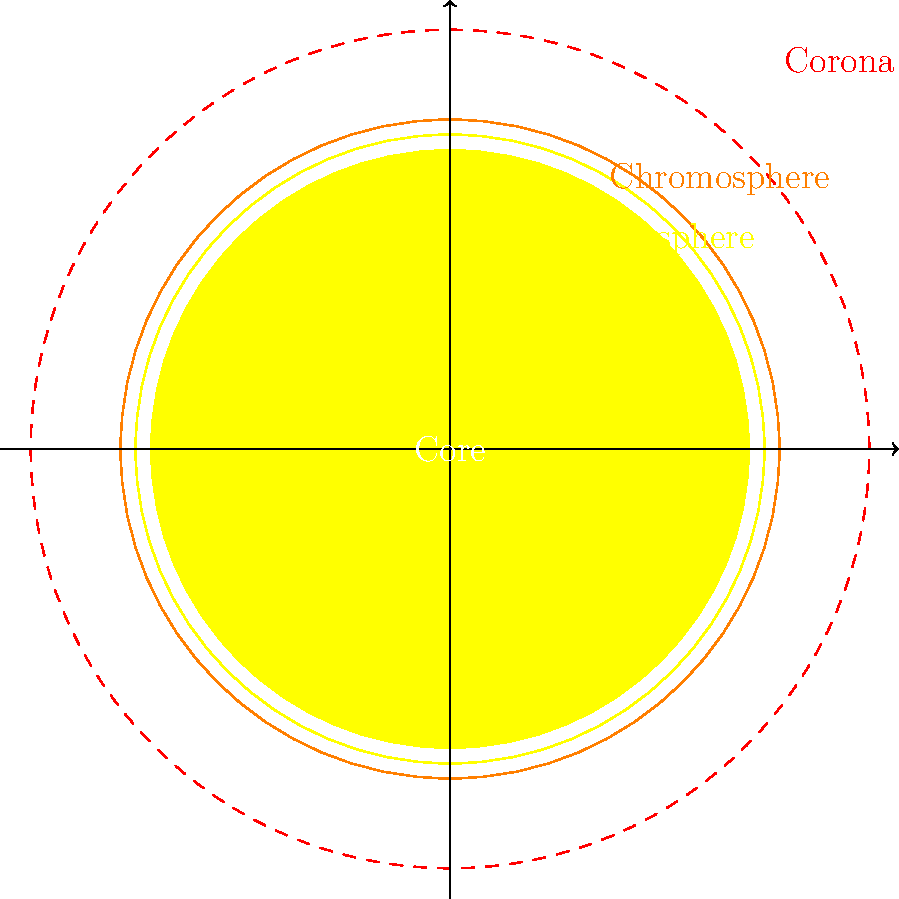In the context of creating 8-bit music inspired by astronomical phenomena, which layer of the Sun's atmosphere would be best represented by high-frequency, shimmering sounds due to its extremely high temperature and dynamic nature? To answer this question, let's break down the layers of the Sun's atmosphere and their characteristics:

1. Photosphere: This is the visible surface of the Sun. It's relatively cool (about 5,800 K) and dense.

2. Chromosphere: This layer is hotter than the photosphere (about 4,000 to 8,000 K) and less dense. It appears reddish during solar eclipses.

3. Corona: This is the outermost layer of the Sun's atmosphere. It's extremely hot (over 1,000,000 K) and less dense than the inner layers.

The corona is the best choice for high-frequency, shimmering sounds in 8-bit music because:

a) It's the hottest layer, with temperatures reaching millions of degrees Kelvin.
b) It's highly dynamic, with solar wind, flares, and coronal mass ejections originating here.
c) Its appearance during solar eclipses is described as shimmering or flickering, which aligns well with high-frequency sounds in music.

In 8-bit music composition, high-frequency sounds could be used to represent the intense energy and dynamic nature of the corona, while lower frequencies might represent the cooler, denser inner layers.
Answer: Corona 